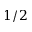<formula> <loc_0><loc_0><loc_500><loc_500>1 / 2</formula> 